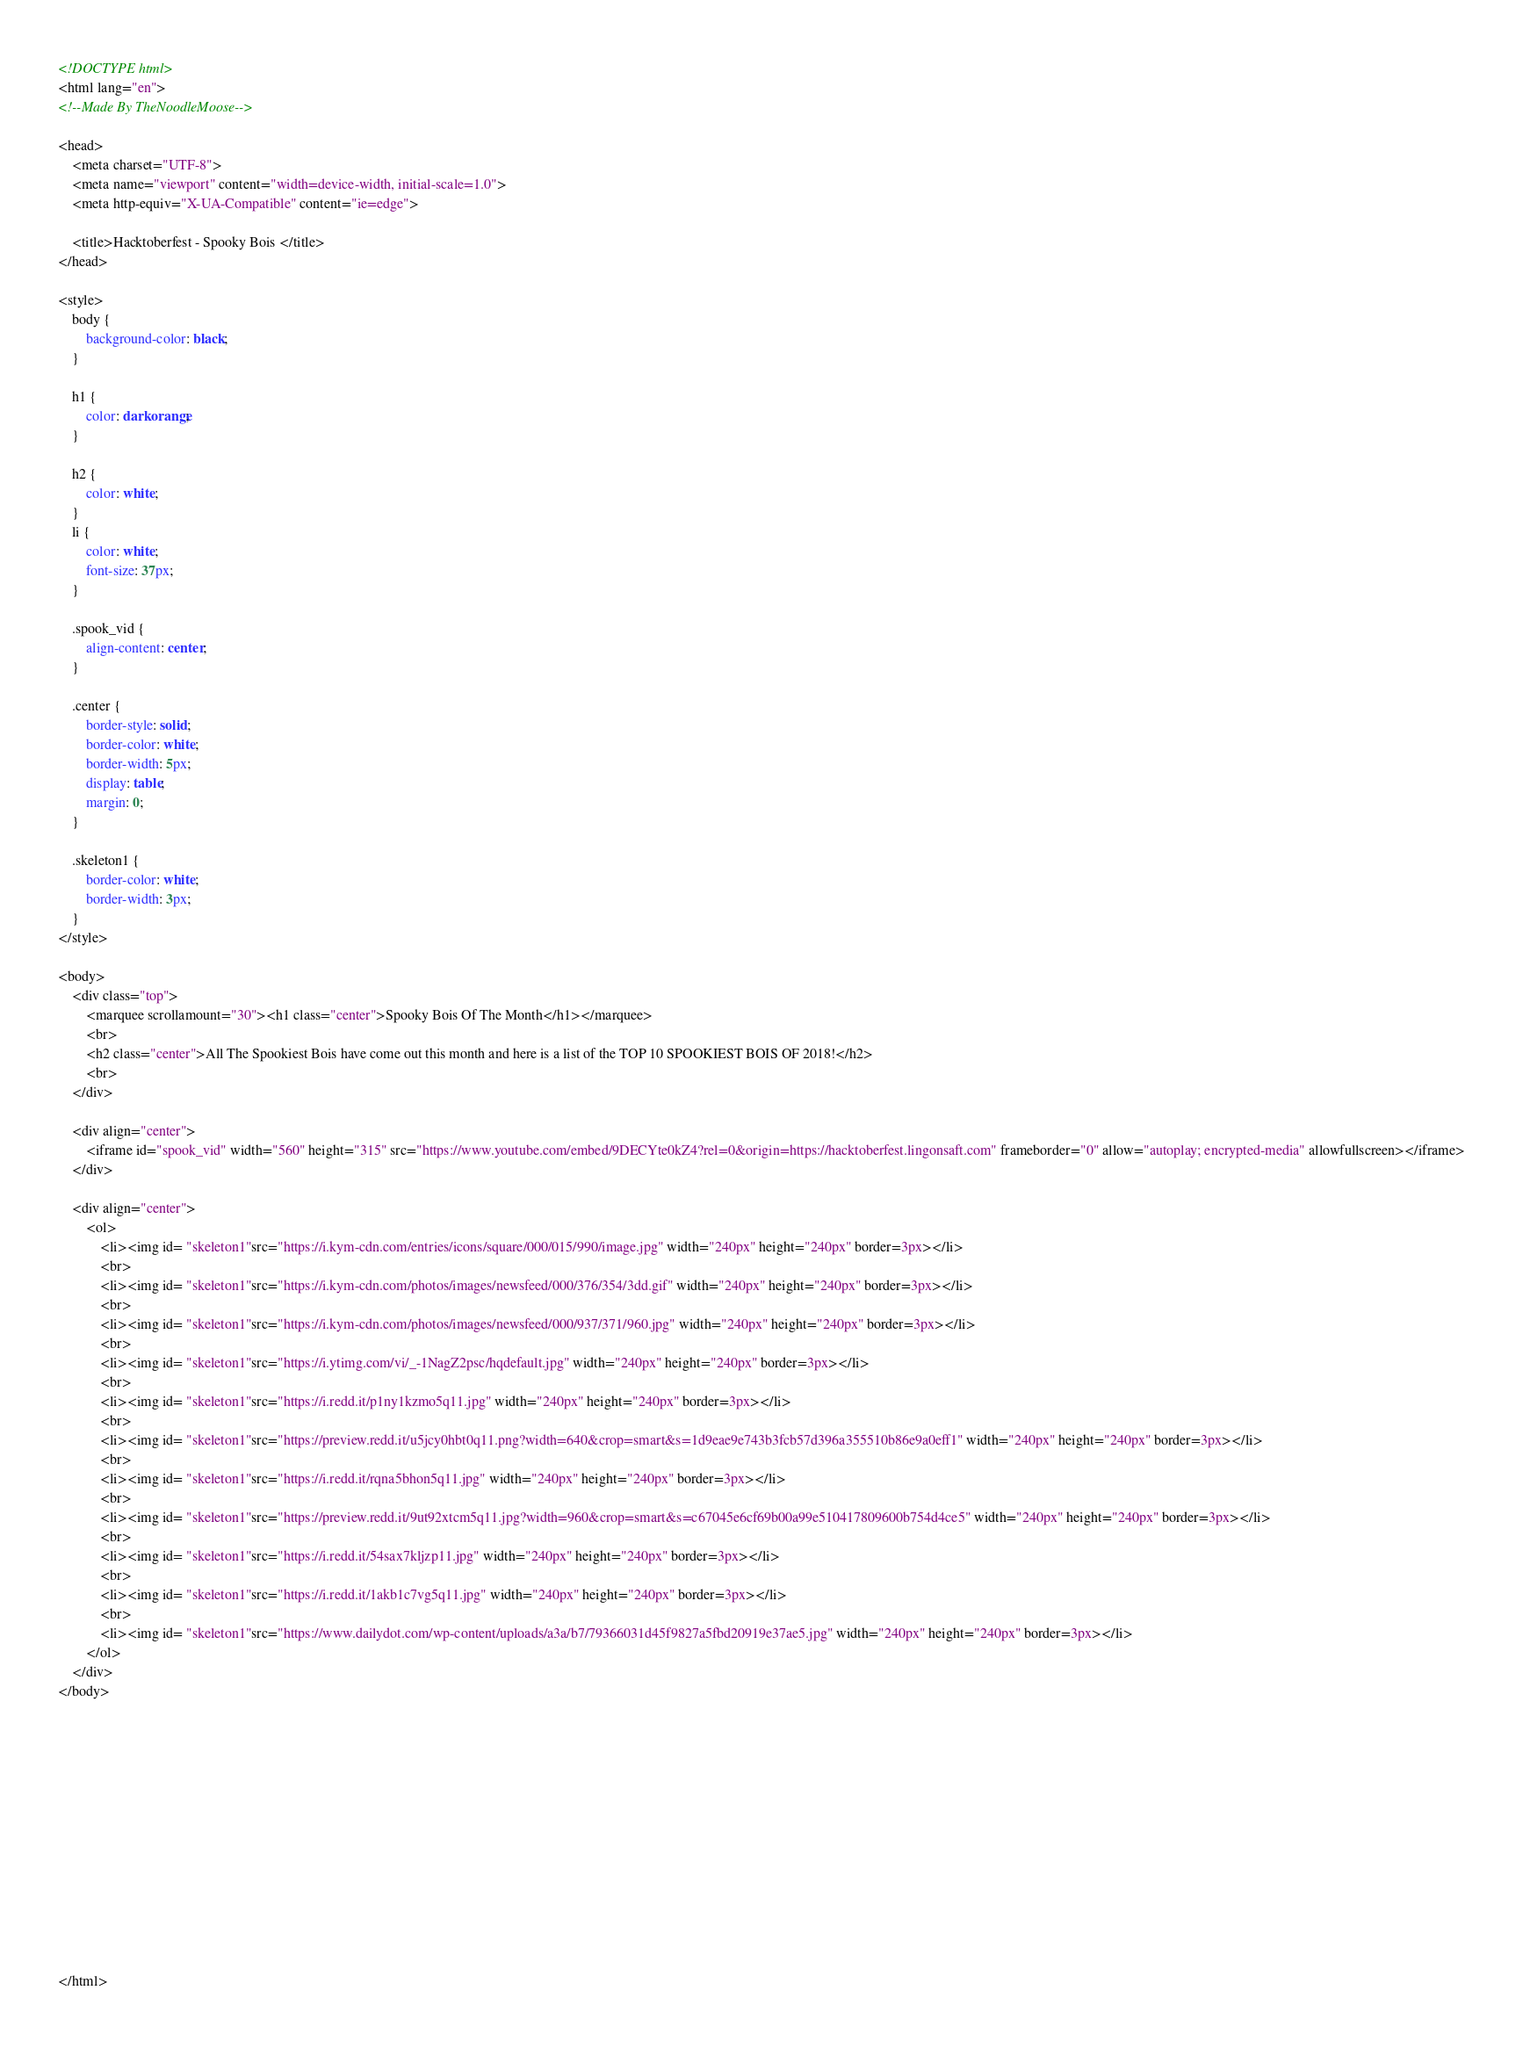Convert code to text. <code><loc_0><loc_0><loc_500><loc_500><_HTML_><!DOCTYPE html>
<html lang="en">
<!--Made By TheNoodleMoose-->

<head>
    <meta charset="UTF-8">
    <meta name="viewport" content="width=device-width, initial-scale=1.0">
    <meta http-equiv="X-UA-Compatible" content="ie=edge">

    <title>Hacktoberfest - Spooky Bois </title>
</head>

<style>
    body {
        background-color: black;
    }

    h1 {
        color: darkorange;
    }

    h2 {
        color: white;
    }
    li {
        color: white;
        font-size: 37px;
    }

    .spook_vid {
        align-content: center;
    }

    .center {
        border-style: solid;
        border-color: white;
        border-width: 5px;
        display: table;
        margin: 0;
    }

    .skeleton1 {
        border-color: white;
        border-width: 3px;
    }
</style>

<body>
    <div class="top">
        <marquee scrollamount="30"><h1 class="center">Spooky Bois Of The Month</h1></marquee>
        <br>
        <h2 class="center">All The Spookiest Bois have come out this month and here is a list of the TOP 10 SPOOKIEST BOIS OF 2018!</h2>
        <br>
    </div>

    <div align="center">
        <iframe id="spook_vid" width="560" height="315" src="https://www.youtube.com/embed/9DECYte0kZ4?rel=0&origin=https://hacktoberfest.lingonsaft.com" frameborder="0" allow="autoplay; encrypted-media" allowfullscreen></iframe>
    </div>

    <div align="center">
        <ol>
            <li><img id= "skeleton1"src="https://i.kym-cdn.com/entries/icons/square/000/015/990/image.jpg" width="240px" height="240px" border=3px></li>
            <br>
            <li><img id= "skeleton1"src="https://i.kym-cdn.com/photos/images/newsfeed/000/376/354/3dd.gif" width="240px" height="240px" border=3px></li>
            <br>
            <li><img id= "skeleton1"src="https://i.kym-cdn.com/photos/images/newsfeed/000/937/371/960.jpg" width="240px" height="240px" border=3px></li>
            <br>
            <li><img id= "skeleton1"src="https://i.ytimg.com/vi/_-1NagZ2psc/hqdefault.jpg" width="240px" height="240px" border=3px></li>
            <br>
            <li><img id= "skeleton1"src="https://i.redd.it/p1ny1kzmo5q11.jpg" width="240px" height="240px" border=3px></li>
            <br>
            <li><img id= "skeleton1"src="https://preview.redd.it/u5jcy0hbt0q11.png?width=640&crop=smart&s=1d9eae9e743b3fcb57d396a355510b86e9a0eff1" width="240px" height="240px" border=3px></li>
            <br>
            <li><img id= "skeleton1"src="https://i.redd.it/rqna5bhon5q11.jpg" width="240px" height="240px" border=3px></li>
            <br>
            <li><img id= "skeleton1"src="https://preview.redd.it/9ut92xtcm5q11.jpg?width=960&crop=smart&s=c67045e6cf69b00a99e510417809600b754d4ce5" width="240px" height="240px" border=3px></li>
            <br>
            <li><img id= "skeleton1"src="https://i.redd.it/54sax7kljzp11.jpg" width="240px" height="240px" border=3px></li>
            <br>
            <li><img id= "skeleton1"src="https://i.redd.it/1akb1c7vg5q11.jpg" width="240px" height="240px" border=3px></li>
            <br>
            <li><img id= "skeleton1"src="https://www.dailydot.com/wp-content/uploads/a3a/b7/79366031d45f9827a5fbd20919e37ae5.jpg" width="240px" height="240px" border=3px></li>
        </ol>
    </div>
</body>














</html>
</code> 